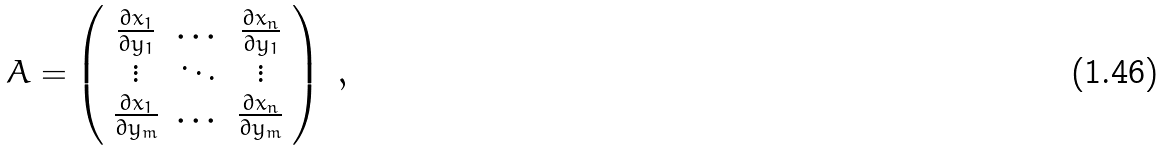Convert formula to latex. <formula><loc_0><loc_0><loc_500><loc_500>A = \left ( \begin{array} { c c c } \frac { \partial x _ { 1 } } { \partial y _ { 1 } } & \dots & \frac { \partial x _ { n } } { \partial y _ { 1 } } \\ \vdots & \ddots & \vdots \\ \frac { \partial x _ { 1 } } { \partial y _ { m } } & \dots & \frac { \partial x _ { n } } { \partial y _ { m } } \end{array} \right ) \ ,</formula> 